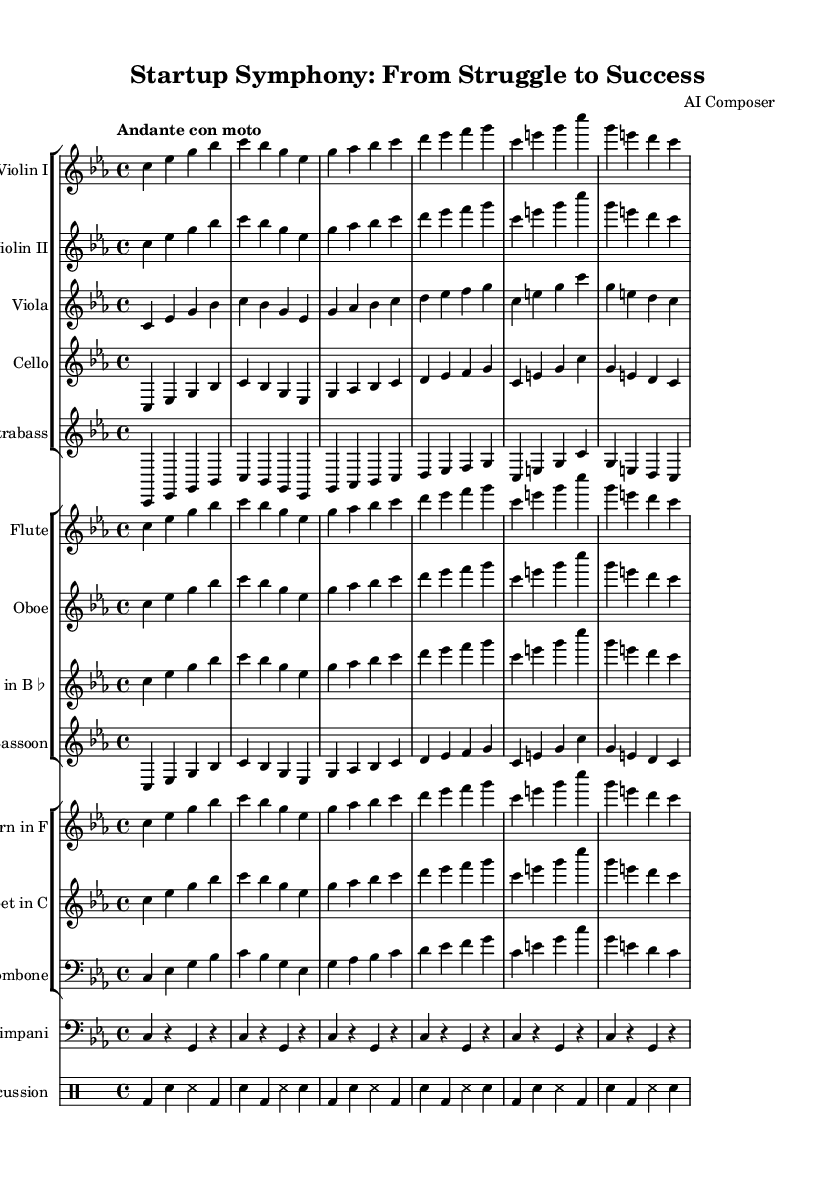What is the key signature of this music? The key signature is C minor, which has three flats: B♭, E♭, and A♭. This is indicated at the beginning of the staff where the key signature is shown.
Answer: C minor What is the time signature of this symphony? The time signature is 4/4, as indicated at the beginning of the music. It means there are four beats in each measure and the quarter note receives one beat.
Answer: 4/4 What is the tempo marking of this piece? The tempo marking is 'Andante con moto,' which suggests a moderate, walking pace with a sense of movement. Tempo markings provide guidance on how fast the piece should be played.
Answer: Andante con moto How many musical instruments are specified in this symphony? There are eleven instruments specified: Violin I, Violin II, Viola, Cello, Contrabass, Flute, Oboe, Clarinet, Bassoon, Horn, Trumpet, Trombone, Timpani, and Percussion. This can be counted from the different staff groups and individual parts.
Answer: Eleven What type of musical structure is used in this symphony? The musical structure appears to follow a call-and-response format, where each instrument or group of instruments interacts with phrases, reflecting the emotional journey of startup founders through harmonies, emphasizing struggles and breakthroughs. This analysis requires listening to the music and examining how the sections relate.
Answer: Call-and-response What is the role of the timpani in this symphony? The timpani plays a rhythmic role, providing a punctuated accent within the piece. In symphonic music, the timpani often marks significant moments that heighten emotional intensity and drama. This can be understood by observing how the timpani part aligns with the overall dynamic.
Answer: Rhythmic accent 